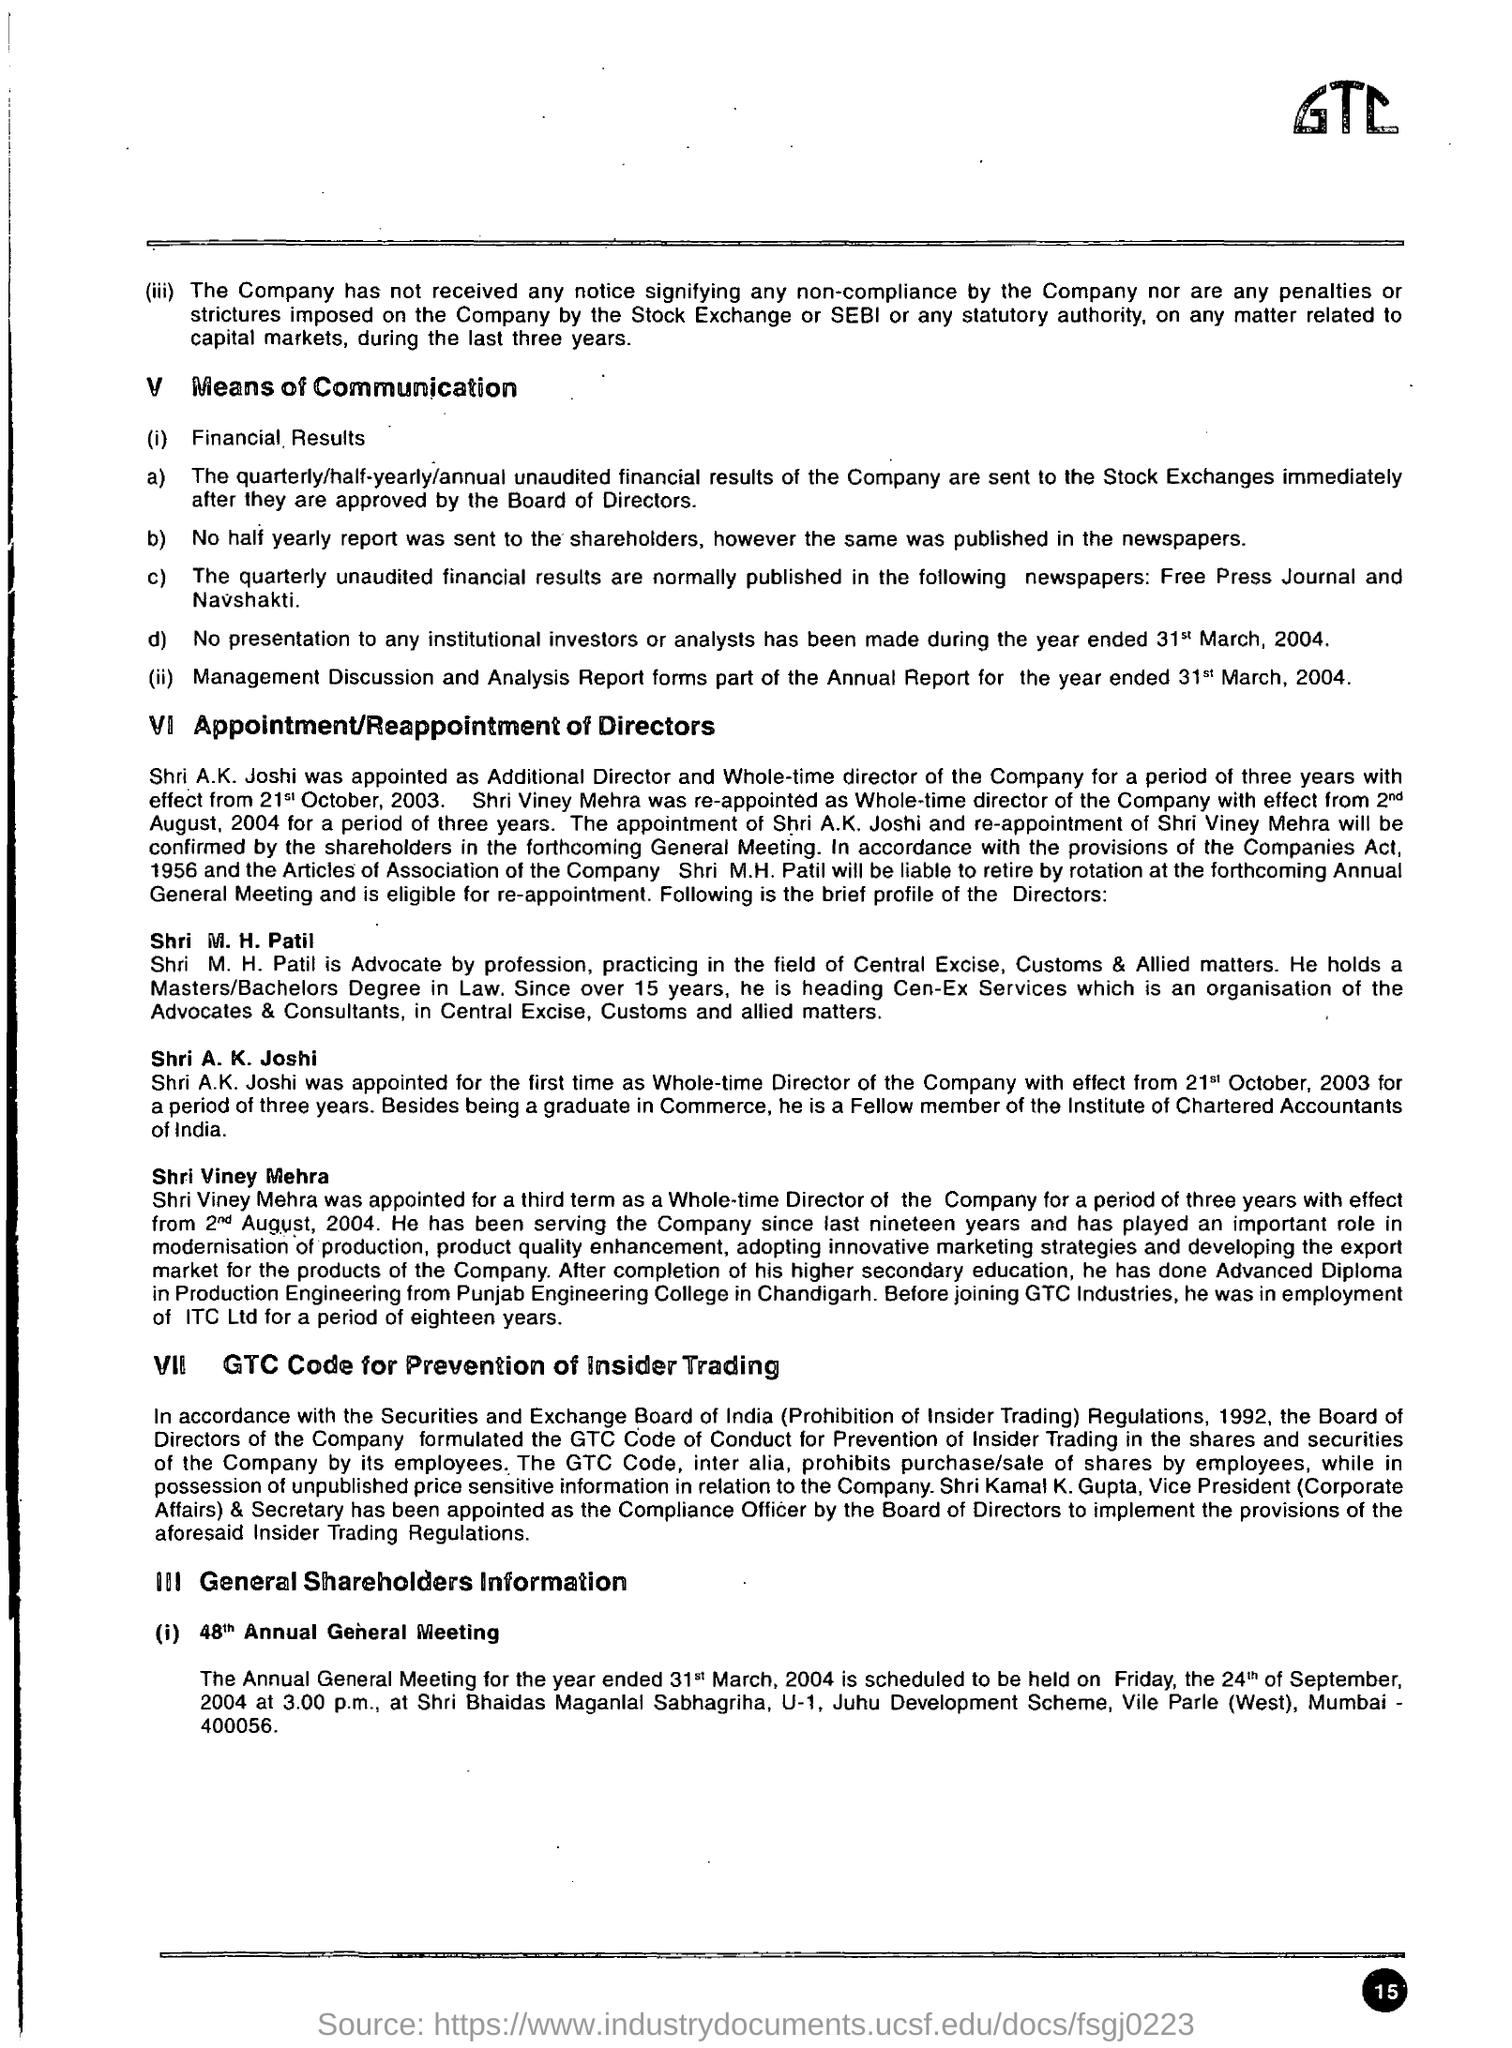Identify some key points in this picture. The name of the company is GTC. 